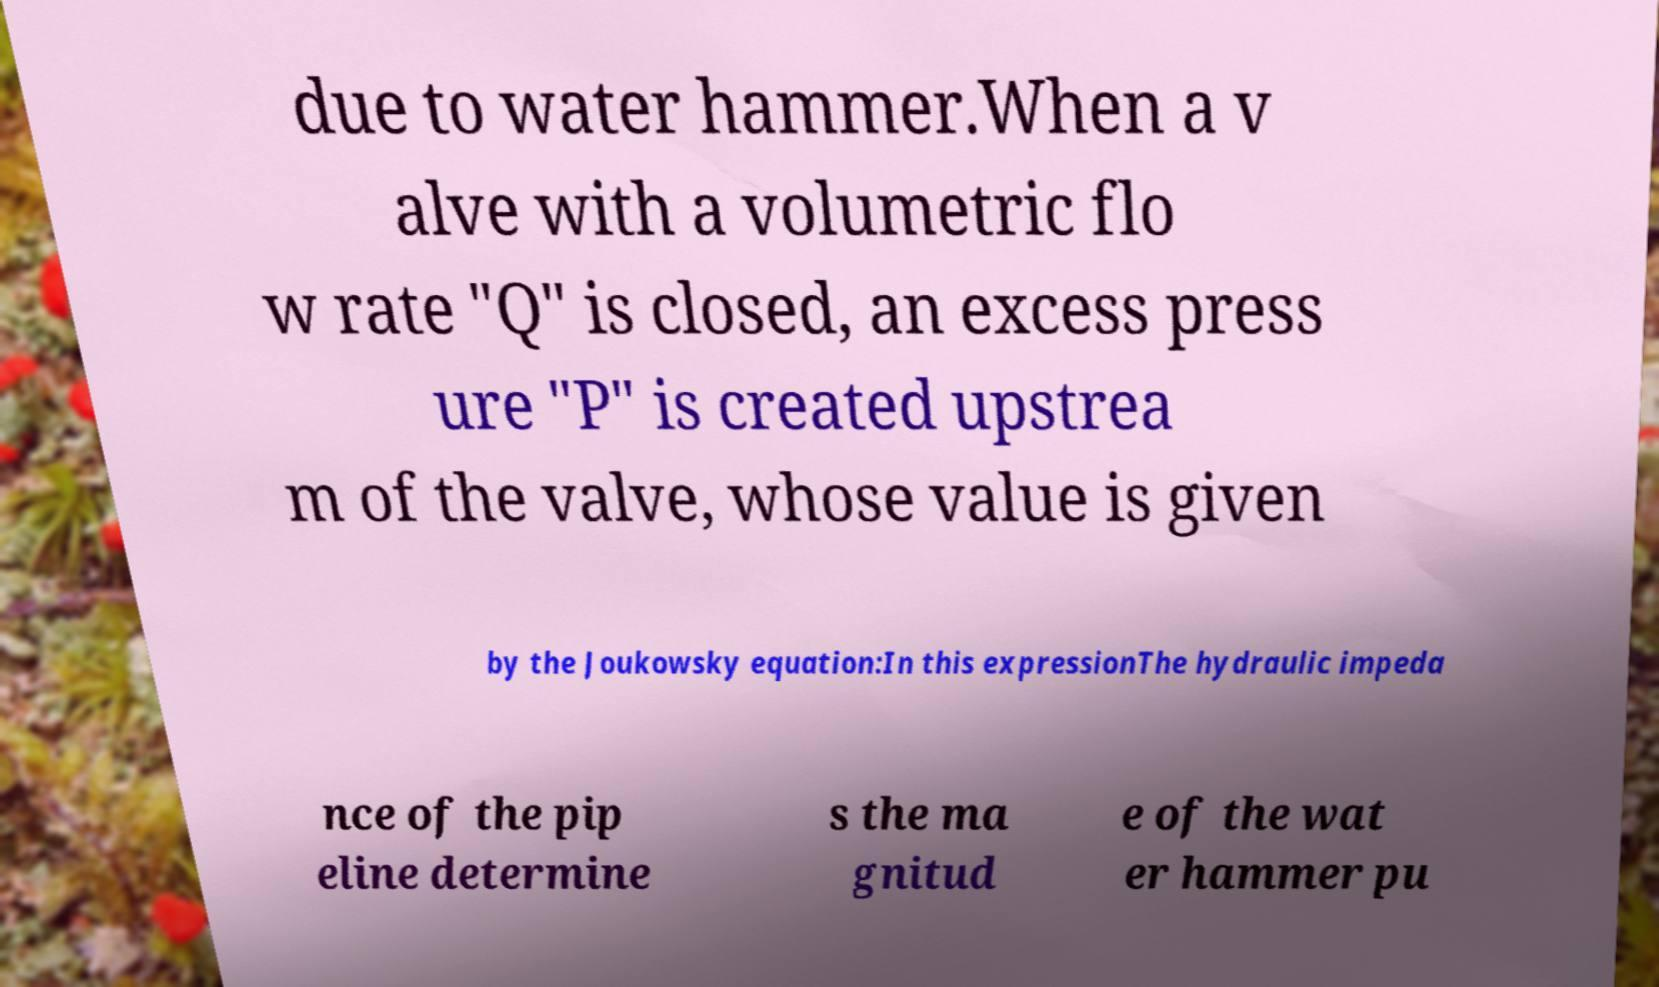Can you accurately transcribe the text from the provided image for me? due to water hammer.When a v alve with a volumetric flo w rate "Q" is closed, an excess press ure "P" is created upstrea m of the valve, whose value is given by the Joukowsky equation:In this expressionThe hydraulic impeda nce of the pip eline determine s the ma gnitud e of the wat er hammer pu 